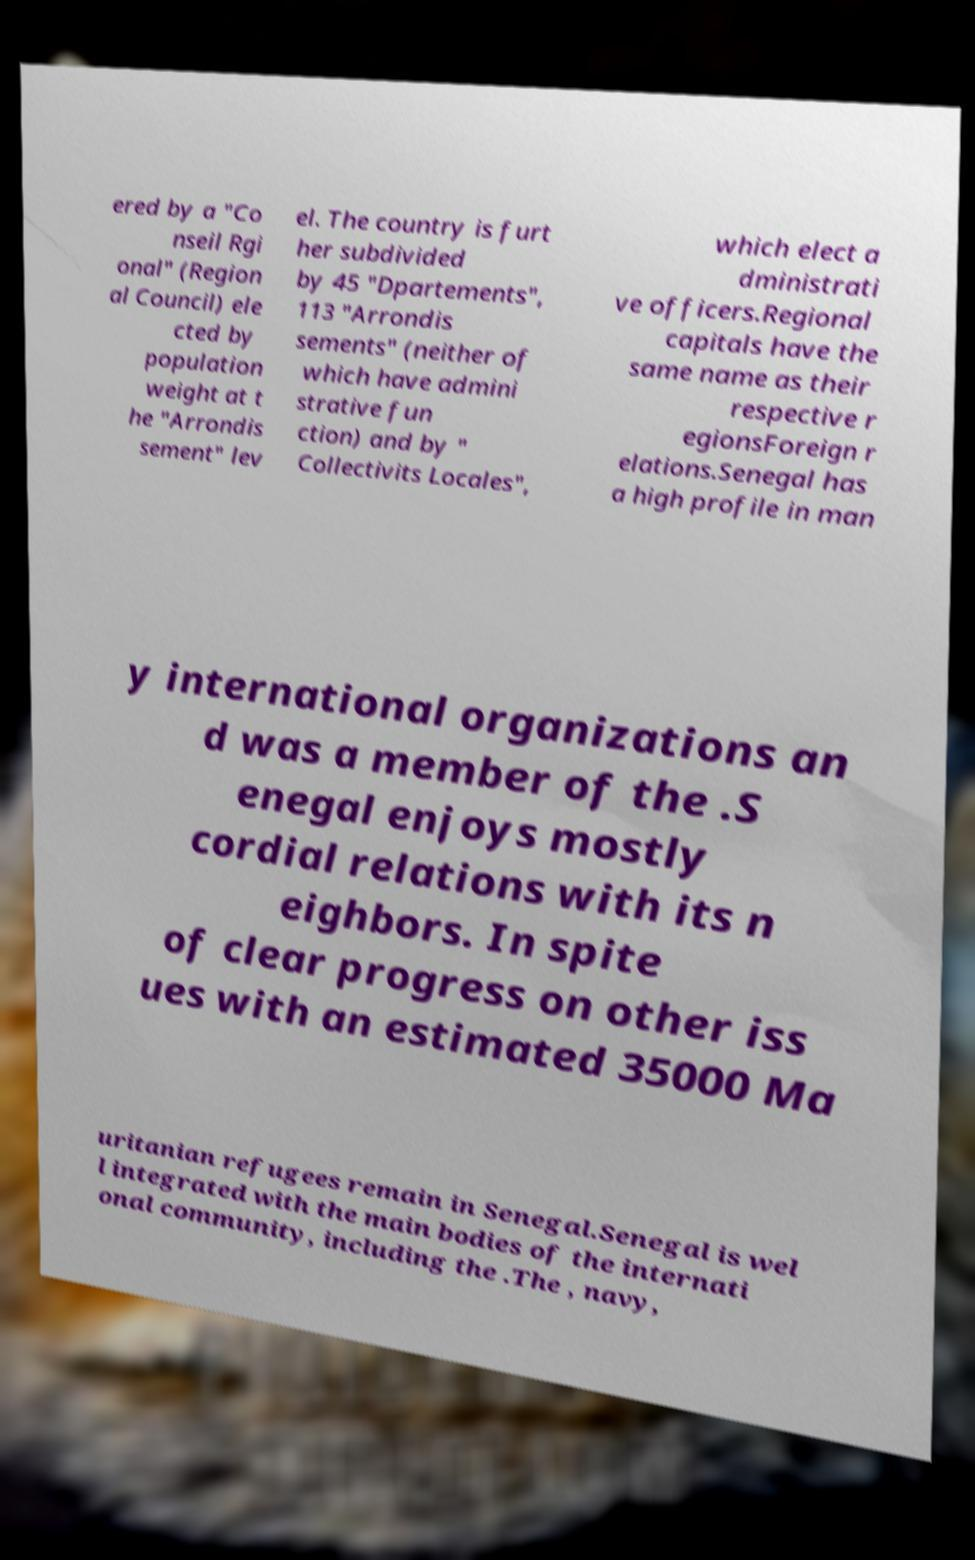Could you assist in decoding the text presented in this image and type it out clearly? ered by a "Co nseil Rgi onal" (Region al Council) ele cted by population weight at t he "Arrondis sement" lev el. The country is furt her subdivided by 45 "Dpartements", 113 "Arrondis sements" (neither of which have admini strative fun ction) and by " Collectivits Locales", which elect a dministrati ve officers.Regional capitals have the same name as their respective r egionsForeign r elations.Senegal has a high profile in man y international organizations an d was a member of the .S enegal enjoys mostly cordial relations with its n eighbors. In spite of clear progress on other iss ues with an estimated 35000 Ma uritanian refugees remain in Senegal.Senegal is wel l integrated with the main bodies of the internati onal community, including the .The , navy, 